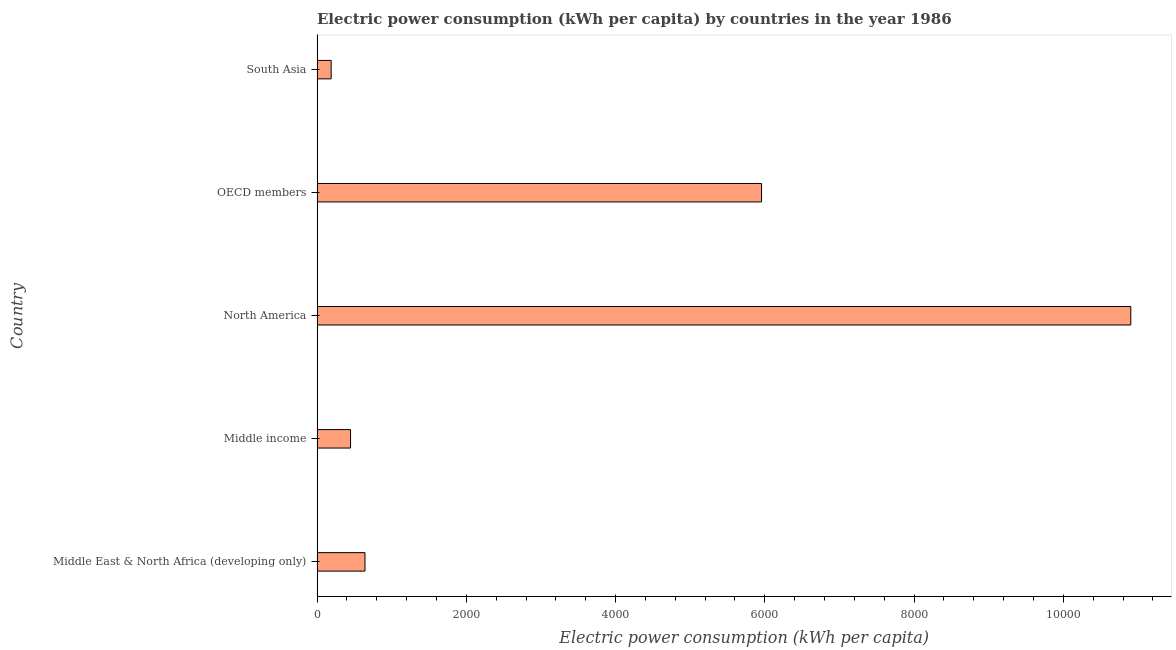Does the graph contain any zero values?
Ensure brevity in your answer.  No. Does the graph contain grids?
Keep it short and to the point. No. What is the title of the graph?
Offer a very short reply. Electric power consumption (kWh per capita) by countries in the year 1986. What is the label or title of the X-axis?
Make the answer very short. Electric power consumption (kWh per capita). What is the electric power consumption in Middle income?
Make the answer very short. 448.79. Across all countries, what is the maximum electric power consumption?
Offer a terse response. 1.09e+04. Across all countries, what is the minimum electric power consumption?
Ensure brevity in your answer.  188.95. In which country was the electric power consumption maximum?
Your response must be concise. North America. What is the sum of the electric power consumption?
Ensure brevity in your answer.  1.81e+04. What is the difference between the electric power consumption in North America and South Asia?
Your answer should be compact. 1.07e+04. What is the average electric power consumption per country?
Offer a terse response. 3628.1. What is the median electric power consumption?
Your answer should be very brief. 642.24. In how many countries, is the electric power consumption greater than 800 kWh per capita?
Offer a terse response. 2. What is the ratio of the electric power consumption in North America to that in South Asia?
Offer a very short reply. 57.71. Is the difference between the electric power consumption in Middle East & North Africa (developing only) and North America greater than the difference between any two countries?
Your answer should be compact. No. What is the difference between the highest and the second highest electric power consumption?
Offer a terse response. 4948.24. Is the sum of the electric power consumption in Middle income and North America greater than the maximum electric power consumption across all countries?
Give a very brief answer. Yes. What is the difference between the highest and the lowest electric power consumption?
Your answer should be compact. 1.07e+04. In how many countries, is the electric power consumption greater than the average electric power consumption taken over all countries?
Your answer should be compact. 2. How many countries are there in the graph?
Ensure brevity in your answer.  5. What is the difference between two consecutive major ticks on the X-axis?
Make the answer very short. 2000. Are the values on the major ticks of X-axis written in scientific E-notation?
Ensure brevity in your answer.  No. What is the Electric power consumption (kWh per capita) in Middle East & North Africa (developing only)?
Make the answer very short. 642.24. What is the Electric power consumption (kWh per capita) in Middle income?
Your response must be concise. 448.79. What is the Electric power consumption (kWh per capita) in North America?
Ensure brevity in your answer.  1.09e+04. What is the Electric power consumption (kWh per capita) of OECD members?
Give a very brief answer. 5956.14. What is the Electric power consumption (kWh per capita) of South Asia?
Your answer should be very brief. 188.95. What is the difference between the Electric power consumption (kWh per capita) in Middle East & North Africa (developing only) and Middle income?
Keep it short and to the point. 193.46. What is the difference between the Electric power consumption (kWh per capita) in Middle East & North Africa (developing only) and North America?
Give a very brief answer. -1.03e+04. What is the difference between the Electric power consumption (kWh per capita) in Middle East & North Africa (developing only) and OECD members?
Make the answer very short. -5313.89. What is the difference between the Electric power consumption (kWh per capita) in Middle East & North Africa (developing only) and South Asia?
Offer a very short reply. 453.29. What is the difference between the Electric power consumption (kWh per capita) in Middle income and North America?
Your answer should be very brief. -1.05e+04. What is the difference between the Electric power consumption (kWh per capita) in Middle income and OECD members?
Your answer should be compact. -5507.35. What is the difference between the Electric power consumption (kWh per capita) in Middle income and South Asia?
Provide a succinct answer. 259.83. What is the difference between the Electric power consumption (kWh per capita) in North America and OECD members?
Your response must be concise. 4948.24. What is the difference between the Electric power consumption (kWh per capita) in North America and South Asia?
Provide a succinct answer. 1.07e+04. What is the difference between the Electric power consumption (kWh per capita) in OECD members and South Asia?
Keep it short and to the point. 5767.18. What is the ratio of the Electric power consumption (kWh per capita) in Middle East & North Africa (developing only) to that in Middle income?
Your answer should be very brief. 1.43. What is the ratio of the Electric power consumption (kWh per capita) in Middle East & North Africa (developing only) to that in North America?
Your response must be concise. 0.06. What is the ratio of the Electric power consumption (kWh per capita) in Middle East & North Africa (developing only) to that in OECD members?
Provide a succinct answer. 0.11. What is the ratio of the Electric power consumption (kWh per capita) in Middle East & North Africa (developing only) to that in South Asia?
Keep it short and to the point. 3.4. What is the ratio of the Electric power consumption (kWh per capita) in Middle income to that in North America?
Your answer should be very brief. 0.04. What is the ratio of the Electric power consumption (kWh per capita) in Middle income to that in OECD members?
Ensure brevity in your answer.  0.07. What is the ratio of the Electric power consumption (kWh per capita) in Middle income to that in South Asia?
Give a very brief answer. 2.38. What is the ratio of the Electric power consumption (kWh per capita) in North America to that in OECD members?
Offer a terse response. 1.83. What is the ratio of the Electric power consumption (kWh per capita) in North America to that in South Asia?
Give a very brief answer. 57.71. What is the ratio of the Electric power consumption (kWh per capita) in OECD members to that in South Asia?
Give a very brief answer. 31.52. 